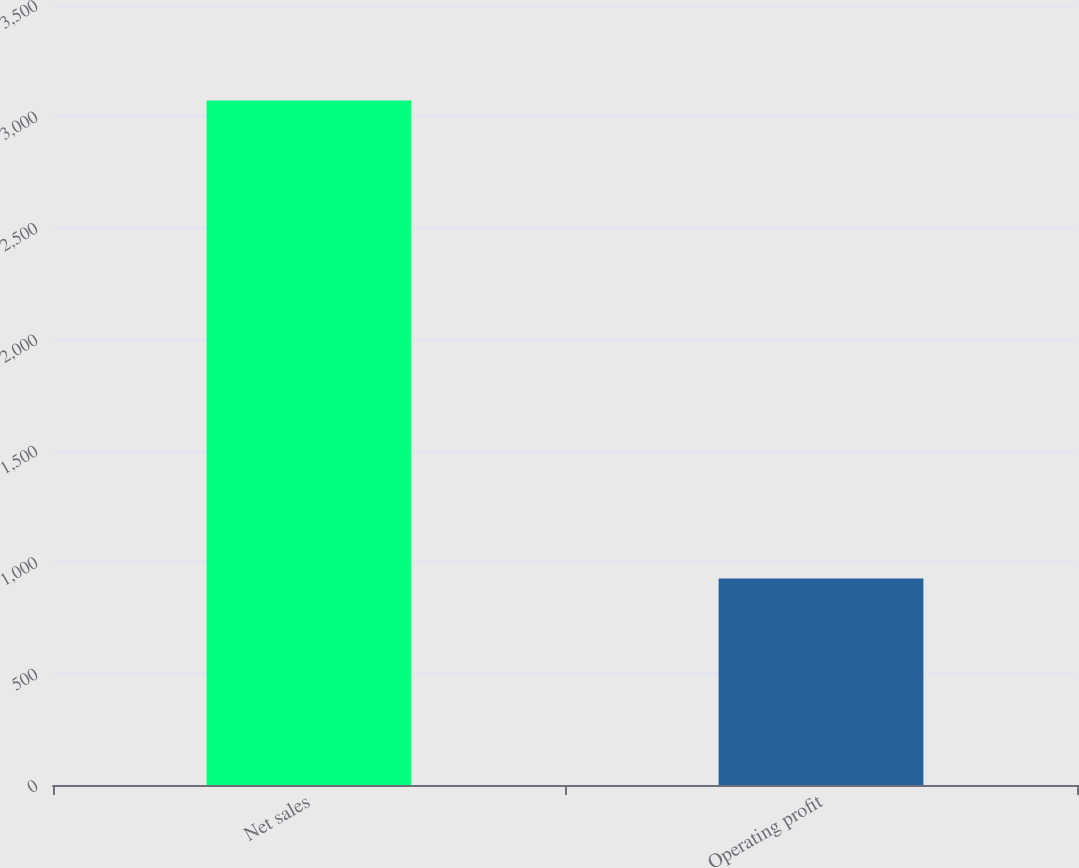<chart> <loc_0><loc_0><loc_500><loc_500><bar_chart><fcel>Net sales<fcel>Operating profit<nl><fcel>3072<fcel>927<nl></chart> 